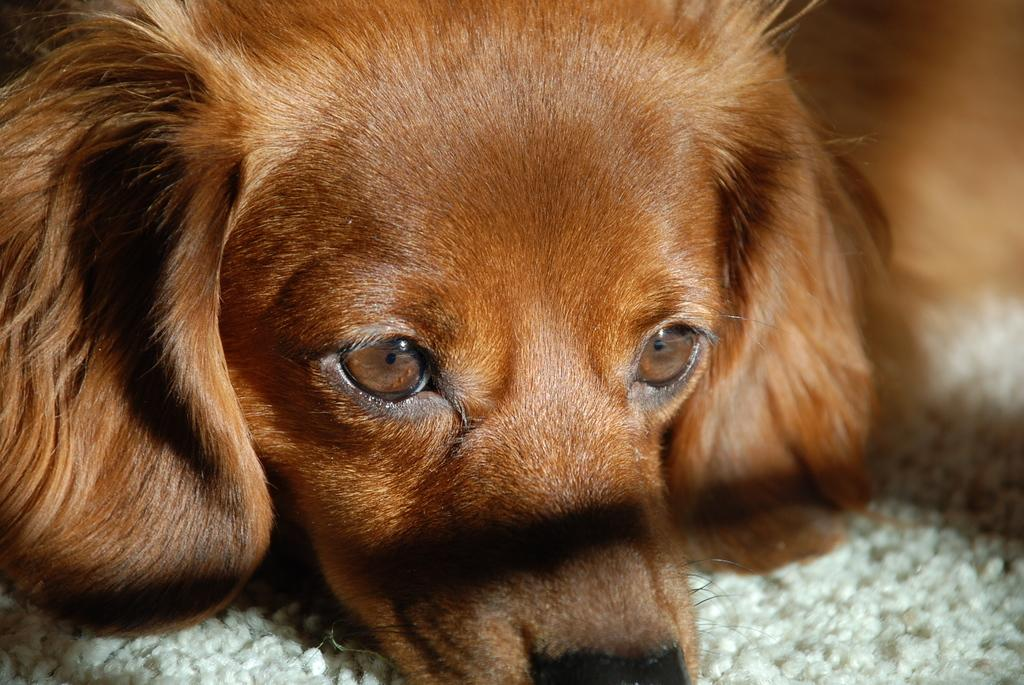What type of animal is in the image? There is a brown color dog in the image. What is the dog standing on in the image? There is a mat at the bottom of the image. How many legs does the nose have in the image? There is no nose present in the image, and therefore no legs can be attributed to it. 